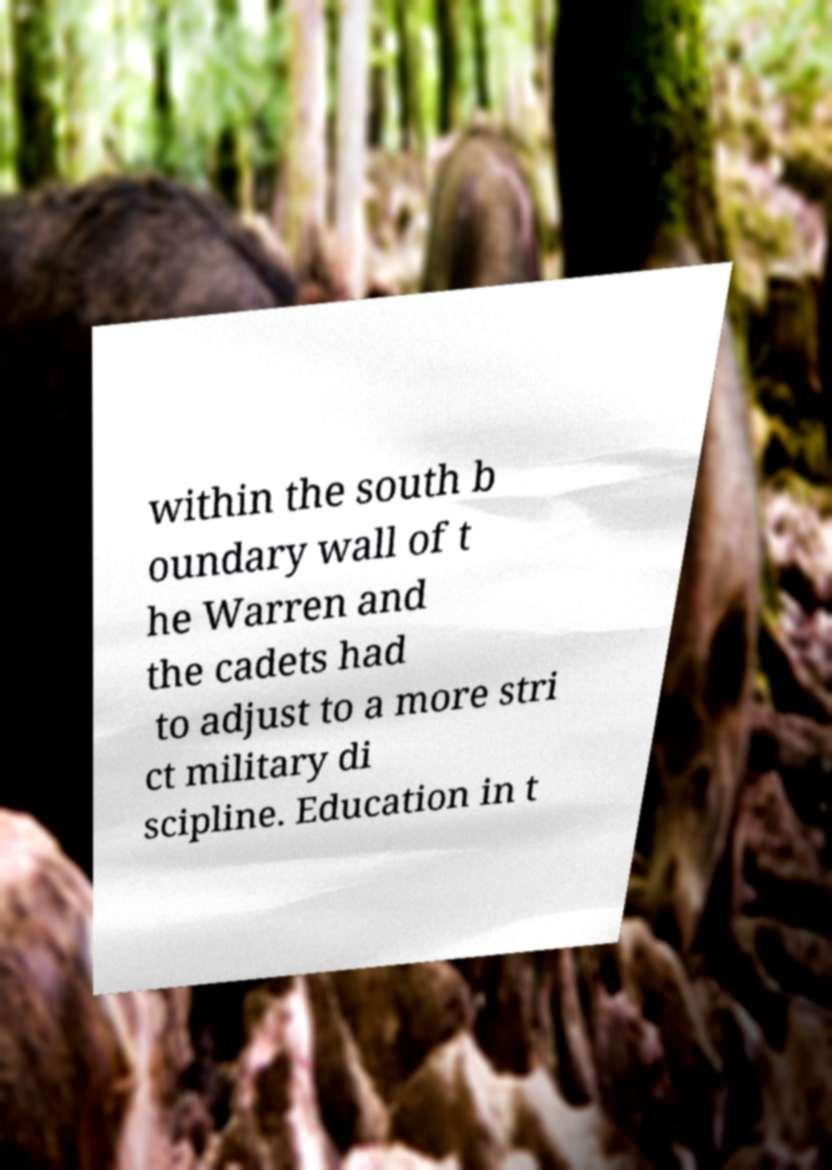Can you accurately transcribe the text from the provided image for me? within the south b oundary wall of t he Warren and the cadets had to adjust to a more stri ct military di scipline. Education in t 